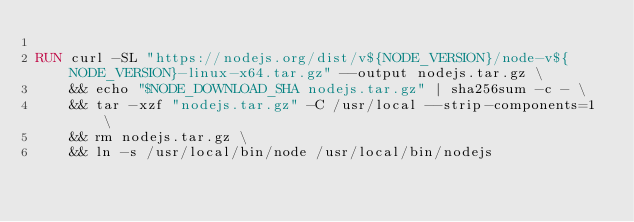Convert code to text. <code><loc_0><loc_0><loc_500><loc_500><_Dockerfile_>
RUN curl -SL "https://nodejs.org/dist/v${NODE_VERSION}/node-v${NODE_VERSION}-linux-x64.tar.gz" --output nodejs.tar.gz \
    && echo "$NODE_DOWNLOAD_SHA nodejs.tar.gz" | sha256sum -c - \
    && tar -xzf "nodejs.tar.gz" -C /usr/local --strip-components=1 \
    && rm nodejs.tar.gz \
    && ln -s /usr/local/bin/node /usr/local/bin/nodejs
</code> 